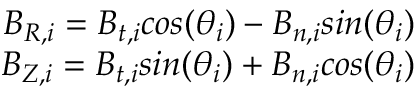Convert formula to latex. <formula><loc_0><loc_0><loc_500><loc_500>\begin{array} { r l } { B _ { R , i } = B _ { t , i } \cos ( \theta _ { i } ) - B _ { n , i } \sin ( \theta _ { i } ) } \\ { B _ { Z , i } = B _ { t , i } \sin ( \theta _ { i } ) + B _ { n , i } \cos ( \theta _ { i } ) } \end{array}</formula> 